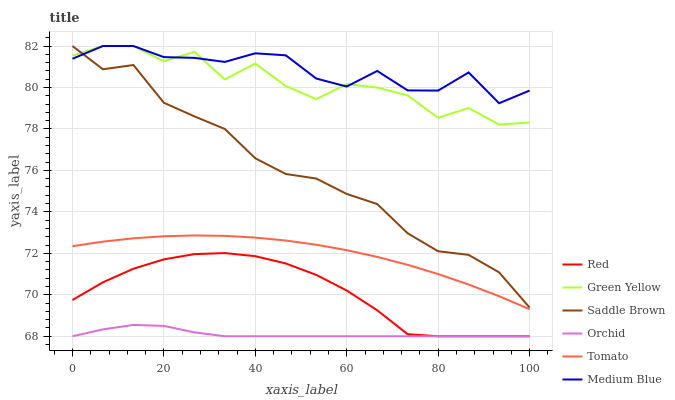Does Orchid have the minimum area under the curve?
Answer yes or no. Yes. Does Medium Blue have the maximum area under the curve?
Answer yes or no. Yes. Does Green Yellow have the minimum area under the curve?
Answer yes or no. No. Does Green Yellow have the maximum area under the curve?
Answer yes or no. No. Is Tomato the smoothest?
Answer yes or no. Yes. Is Green Yellow the roughest?
Answer yes or no. Yes. Is Medium Blue the smoothest?
Answer yes or no. No. Is Medium Blue the roughest?
Answer yes or no. No. Does Red have the lowest value?
Answer yes or no. Yes. Does Green Yellow have the lowest value?
Answer yes or no. No. Does Saddle Brown have the highest value?
Answer yes or no. Yes. Does Red have the highest value?
Answer yes or no. No. Is Orchid less than Medium Blue?
Answer yes or no. Yes. Is Saddle Brown greater than Orchid?
Answer yes or no. Yes. Does Medium Blue intersect Green Yellow?
Answer yes or no. Yes. Is Medium Blue less than Green Yellow?
Answer yes or no. No. Is Medium Blue greater than Green Yellow?
Answer yes or no. No. Does Orchid intersect Medium Blue?
Answer yes or no. No. 